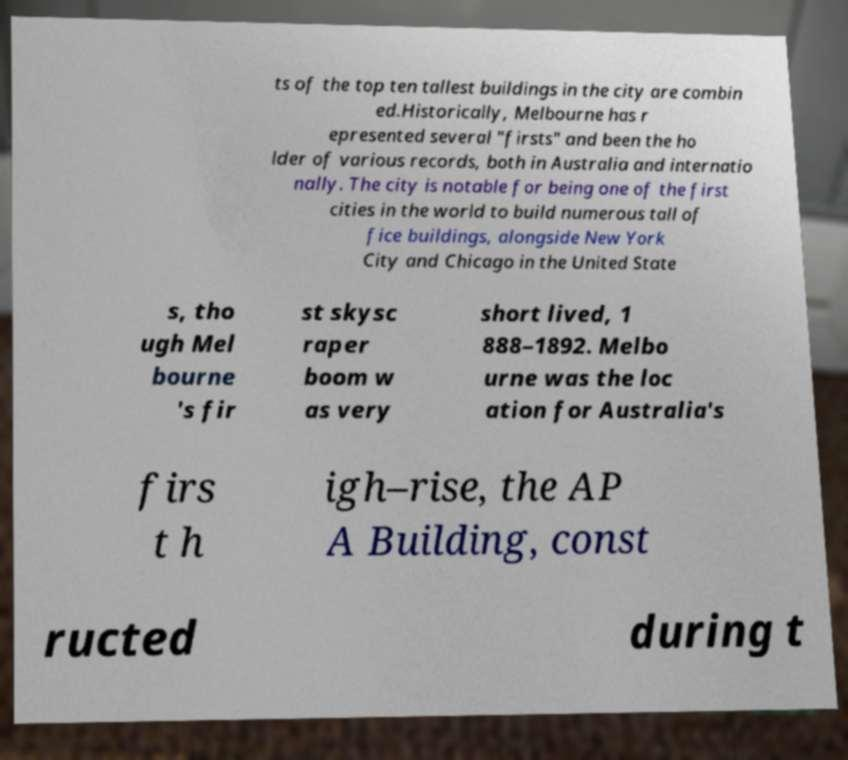What messages or text are displayed in this image? I need them in a readable, typed format. ts of the top ten tallest buildings in the city are combin ed.Historically, Melbourne has r epresented several "firsts" and been the ho lder of various records, both in Australia and internatio nally. The city is notable for being one of the first cities in the world to build numerous tall of fice buildings, alongside New York City and Chicago in the United State s, tho ugh Mel bourne 's fir st skysc raper boom w as very short lived, 1 888–1892. Melbo urne was the loc ation for Australia's firs t h igh–rise, the AP A Building, const ructed during t 